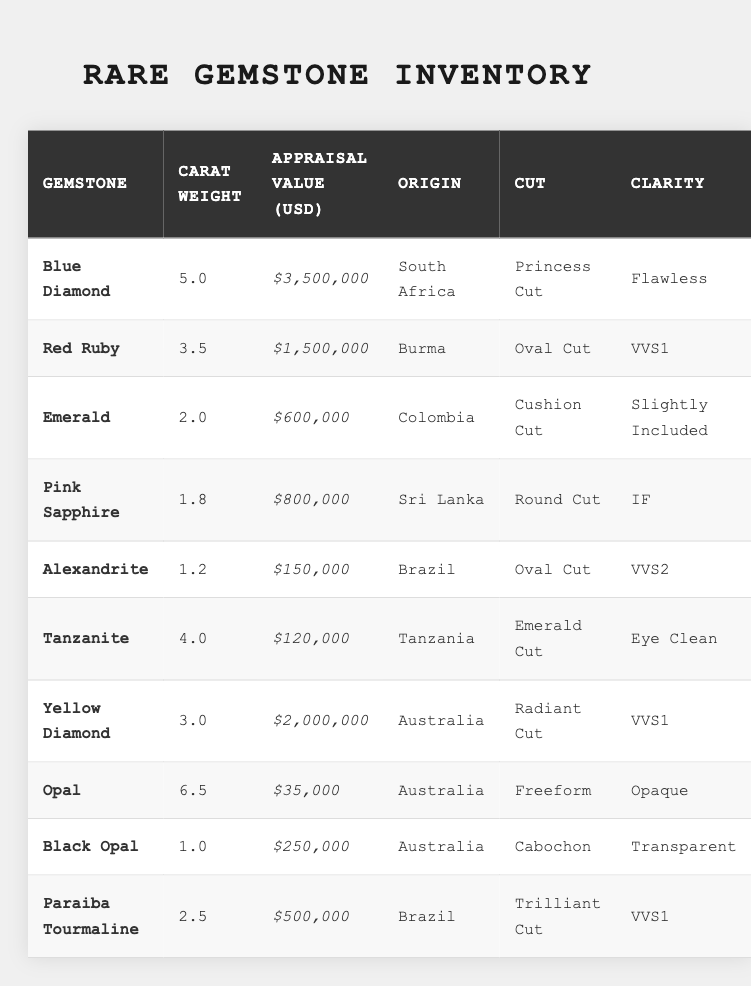What is the appraisal value of the Blue Diamond? The Blue Diamond's appraisal value is listed as $3,500,000 in the table.
Answer: $3,500,000 Which gemstone has the highest carat weight? The Blue Diamond has the highest carat weight of 5.0 compared to the other gemstones listed in the table.
Answer: Blue Diamond Is the clarity of the Emerald rated as "Flawless"? The clarity of the Emerald is rated as "Slightly Included," which is not the same as "Flawless."
Answer: No What is the total appraisal value of the Red Ruby and the Yellow Diamond? The appraisal values for the Red Ruby and Yellow Diamond are $1,500,000 and $2,000,000, respectively. Adding them gives $1,500,000 + $2,000,000 = $3,500,000.
Answer: $3,500,000 Which gemstone from Brazil has the highest appraisal value? The Paraiba Tourmaline is the only gemstone from Brazil in the table and has an appraisal value of $500,000. Hence, it is the gemstone with the highest value from Brazil.
Answer: Paraiba Tourmaline Compare the carat weights of the Black Opal and the Tanzanite. Which is heavier? The Black Opal has a carat weight of 1.0 while the Tanzanite has a carat weight of 4.0, which makes Tanzanite heavier than Black Opal.
Answer: Tanzanite What is the average appraisal value of the gemstones from Australia? The appraisal values of gemstones from Australia are $2,000,000 (Yellow Diamond) and $35,000 (Opal). Their total is $2,035,000, and the average is $2,035,000/2 = $1,017,500.
Answer: $1,017,500 Are there any gemstones listed from Tanzania? Yes, the Tanzanite is the gemstone listed in the table that originates from Tanzania.
Answer: Yes Which gemstone has the lowest appraisal value, and what is that value? The Opal has the lowest appraisal value listed in the table, which is $35,000.
Answer: $35,000 What is the difference in carat weight between the Pink Sapphire and the Alexandrite? The Pink Sapphire has a carat weight of 1.8, and the Alexandrite is 1.2. The difference is calculated as 1.8 - 1.2 = 0.6.
Answer: 0.6 carats Which gemstone has an appraisal value greater than $1,000,000 and is from Burma? The Red Ruby, with an appraisal value of $1,500,000, meets both criteria—a value over $1,000,000 and originating from Burma.
Answer: Red Ruby 